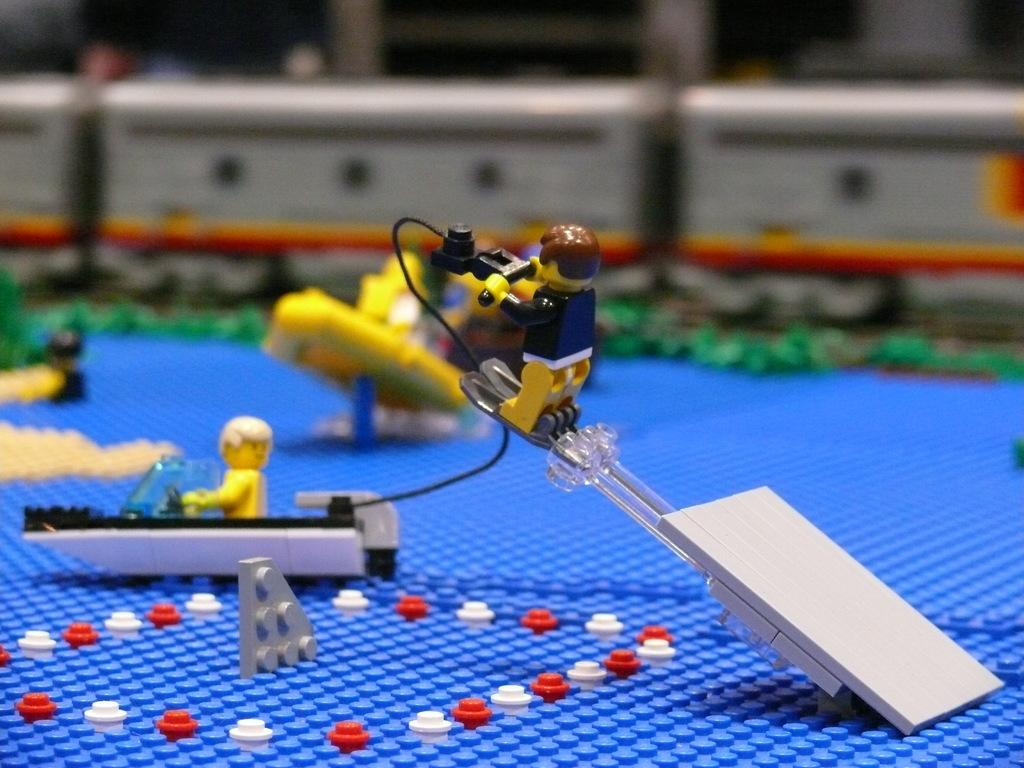What objects are on the black surface in the image? There are toys on a black object in the image. Can you describe the background of the image? The background of the image is blurred. What type of degree is being awarded to the celery in the image? There is no celery or degree present in the image. 